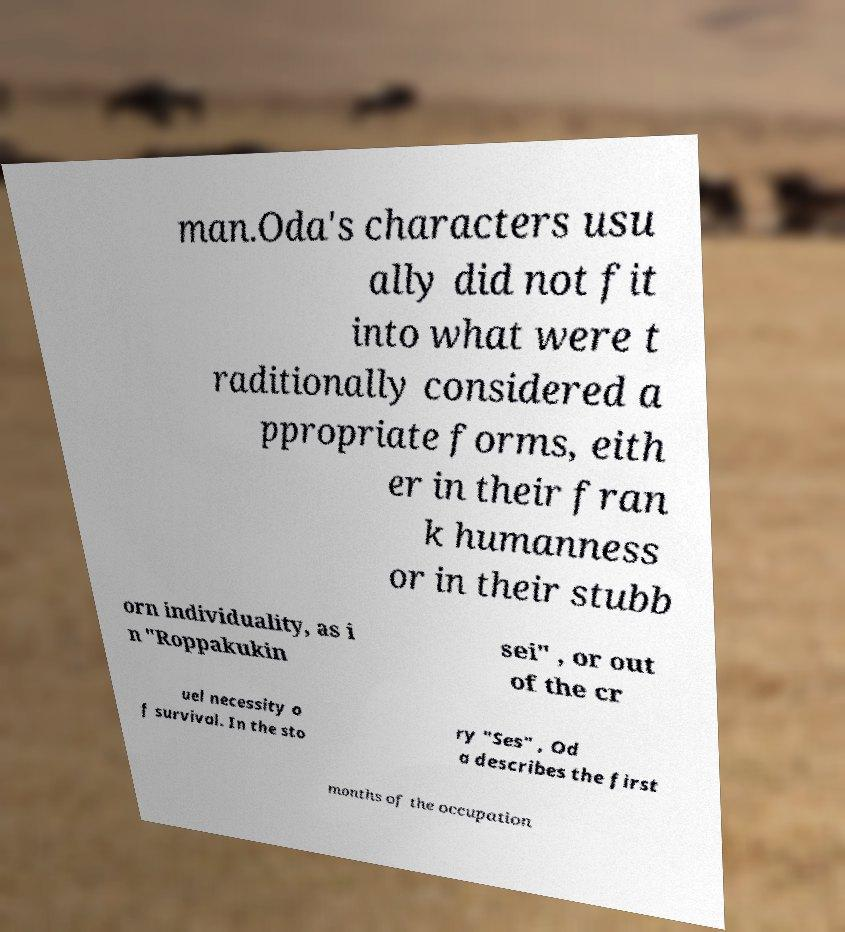For documentation purposes, I need the text within this image transcribed. Could you provide that? man.Oda's characters usu ally did not fit into what were t raditionally considered a ppropriate forms, eith er in their fran k humanness or in their stubb orn individuality, as i n "Roppakukin sei" , or out of the cr uel necessity o f survival. In the sto ry "Ses" , Od a describes the first months of the occupation 